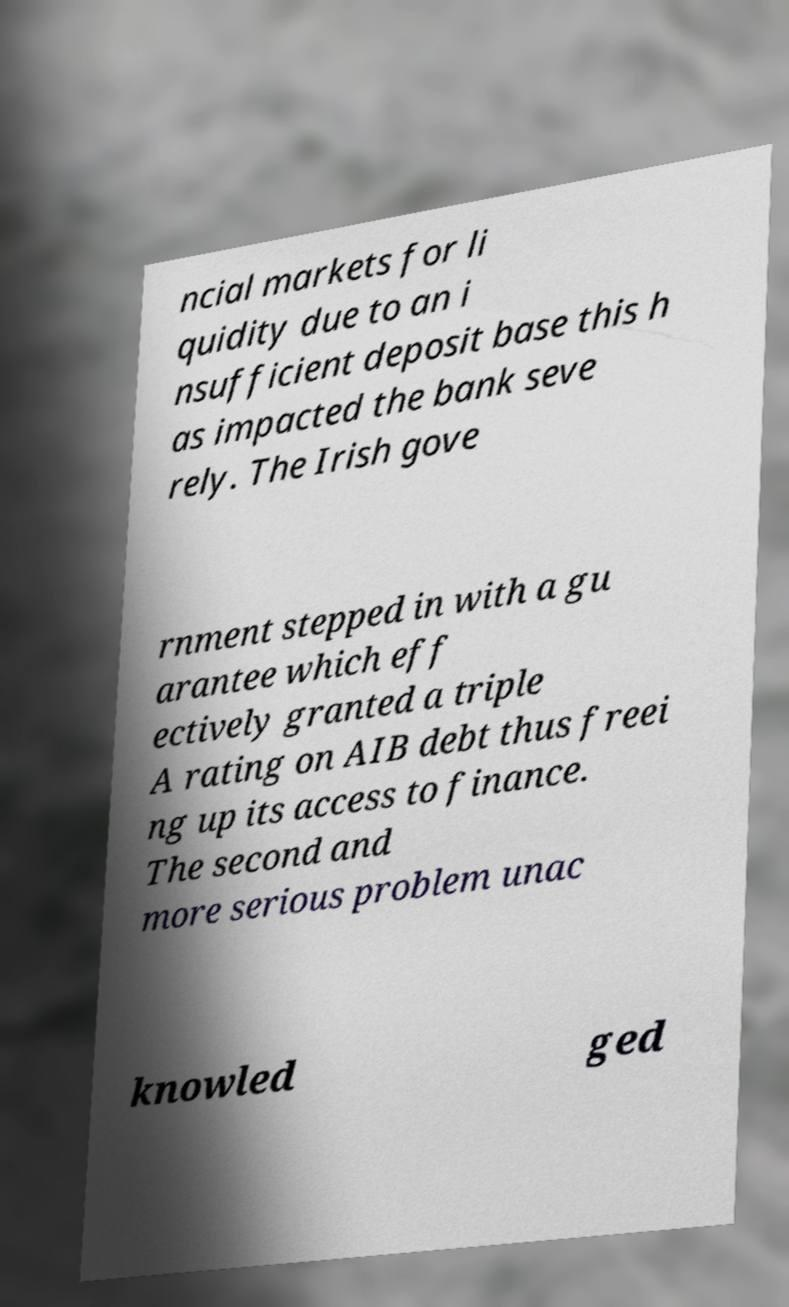There's text embedded in this image that I need extracted. Can you transcribe it verbatim? ncial markets for li quidity due to an i nsufficient deposit base this h as impacted the bank seve rely. The Irish gove rnment stepped in with a gu arantee which eff ectively granted a triple A rating on AIB debt thus freei ng up its access to finance. The second and more serious problem unac knowled ged 